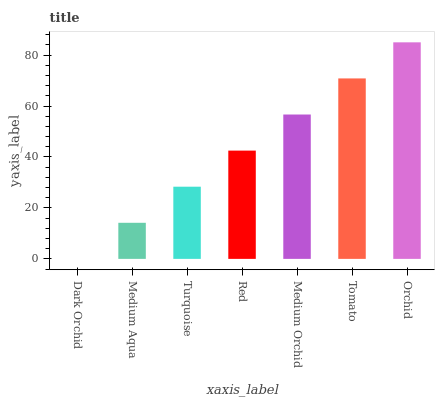Is Dark Orchid the minimum?
Answer yes or no. Yes. Is Orchid the maximum?
Answer yes or no. Yes. Is Medium Aqua the minimum?
Answer yes or no. No. Is Medium Aqua the maximum?
Answer yes or no. No. Is Medium Aqua greater than Dark Orchid?
Answer yes or no. Yes. Is Dark Orchid less than Medium Aqua?
Answer yes or no. Yes. Is Dark Orchid greater than Medium Aqua?
Answer yes or no. No. Is Medium Aqua less than Dark Orchid?
Answer yes or no. No. Is Red the high median?
Answer yes or no. Yes. Is Red the low median?
Answer yes or no. Yes. Is Tomato the high median?
Answer yes or no. No. Is Tomato the low median?
Answer yes or no. No. 